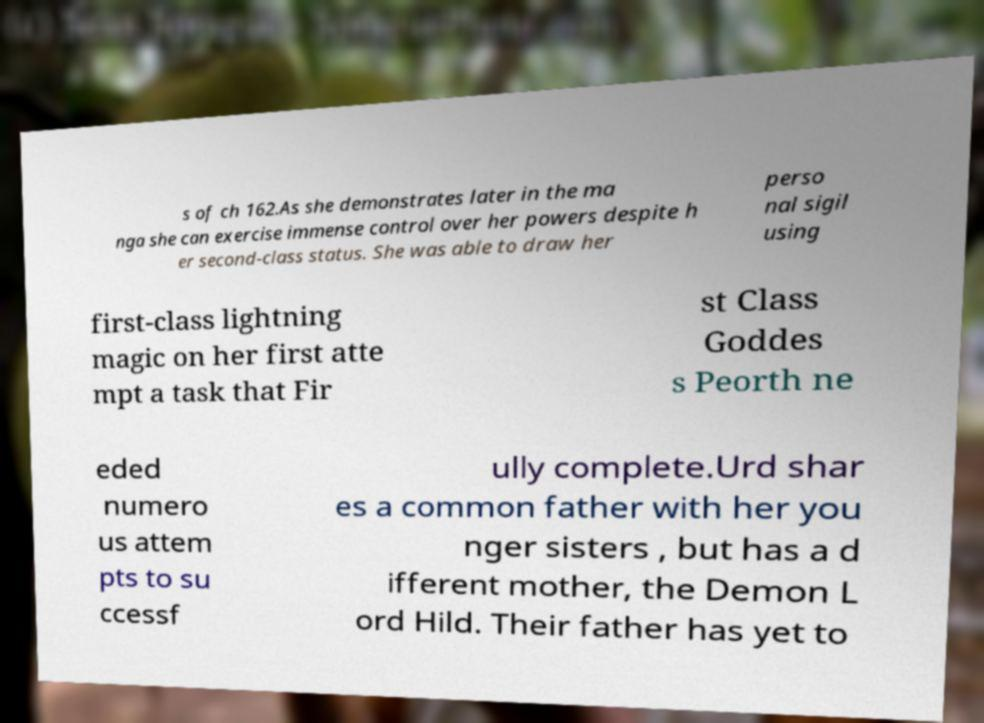What messages or text are displayed in this image? I need them in a readable, typed format. s of ch 162.As she demonstrates later in the ma nga she can exercise immense control over her powers despite h er second-class status. She was able to draw her perso nal sigil using first-class lightning magic on her first atte mpt a task that Fir st Class Goddes s Peorth ne eded numero us attem pts to su ccessf ully complete.Urd shar es a common father with her you nger sisters , but has a d ifferent mother, the Demon L ord Hild. Their father has yet to 